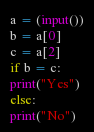Convert code to text. <code><loc_0><loc_0><loc_500><loc_500><_Python_>a = (input())
b = a[0]
c = a[2]
if b = c:
print("Yes")
else:
print("No")
</code> 